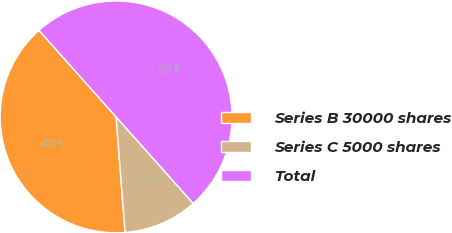Convert chart. <chart><loc_0><loc_0><loc_500><loc_500><pie_chart><fcel>Series B 30000 shares<fcel>Series C 5000 shares<fcel>Total<nl><fcel>39.65%<fcel>10.35%<fcel>50.0%<nl></chart> 